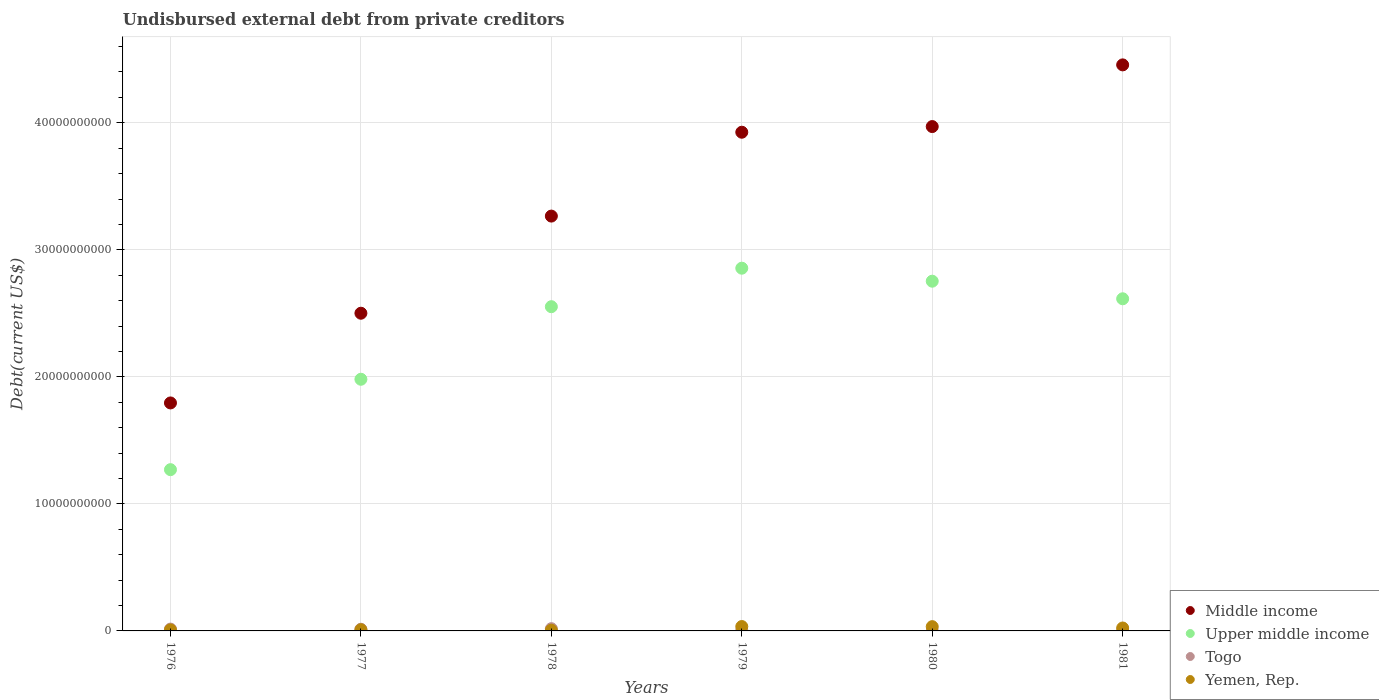How many different coloured dotlines are there?
Provide a succinct answer. 4. What is the total debt in Upper middle income in 1976?
Offer a terse response. 1.27e+1. Across all years, what is the maximum total debt in Middle income?
Your response must be concise. 4.46e+1. Across all years, what is the minimum total debt in Yemen, Rep.?
Your answer should be compact. 5.78e+07. In which year was the total debt in Upper middle income maximum?
Keep it short and to the point. 1979. In which year was the total debt in Middle income minimum?
Offer a very short reply. 1976. What is the total total debt in Upper middle income in the graph?
Your response must be concise. 1.40e+11. What is the difference between the total debt in Upper middle income in 1978 and that in 1980?
Make the answer very short. -2.01e+09. What is the difference between the total debt in Yemen, Rep. in 1980 and the total debt in Upper middle income in 1976?
Offer a very short reply. -1.24e+1. What is the average total debt in Togo per year?
Make the answer very short. 8.50e+07. In the year 1978, what is the difference between the total debt in Yemen, Rep. and total debt in Togo?
Provide a succinct answer. -1.19e+08. What is the ratio of the total debt in Middle income in 1976 to that in 1977?
Your answer should be very brief. 0.72. What is the difference between the highest and the second highest total debt in Togo?
Ensure brevity in your answer.  3.24e+07. What is the difference between the highest and the lowest total debt in Middle income?
Offer a very short reply. 2.66e+1. Is it the case that in every year, the sum of the total debt in Togo and total debt in Middle income  is greater than the sum of total debt in Upper middle income and total debt in Yemen, Rep.?
Offer a terse response. Yes. Is it the case that in every year, the sum of the total debt in Upper middle income and total debt in Togo  is greater than the total debt in Yemen, Rep.?
Keep it short and to the point. Yes. Is the total debt in Yemen, Rep. strictly greater than the total debt in Togo over the years?
Ensure brevity in your answer.  No. Is the total debt in Upper middle income strictly less than the total debt in Togo over the years?
Keep it short and to the point. No. Does the graph contain any zero values?
Offer a terse response. No. Does the graph contain grids?
Your answer should be very brief. Yes. Where does the legend appear in the graph?
Your answer should be very brief. Bottom right. How are the legend labels stacked?
Make the answer very short. Vertical. What is the title of the graph?
Give a very brief answer. Undisbursed external debt from private creditors. Does "Kiribati" appear as one of the legend labels in the graph?
Offer a very short reply. No. What is the label or title of the X-axis?
Ensure brevity in your answer.  Years. What is the label or title of the Y-axis?
Give a very brief answer. Debt(current US$). What is the Debt(current US$) of Middle income in 1976?
Your response must be concise. 1.79e+1. What is the Debt(current US$) of Upper middle income in 1976?
Give a very brief answer. 1.27e+1. What is the Debt(current US$) in Togo in 1976?
Offer a very short reply. 1.44e+08. What is the Debt(current US$) in Yemen, Rep. in 1976?
Offer a very short reply. 8.22e+07. What is the Debt(current US$) in Middle income in 1977?
Make the answer very short. 2.50e+1. What is the Debt(current US$) of Upper middle income in 1977?
Ensure brevity in your answer.  1.98e+1. What is the Debt(current US$) in Togo in 1977?
Provide a short and direct response. 1.32e+08. What is the Debt(current US$) in Yemen, Rep. in 1977?
Make the answer very short. 9.27e+07. What is the Debt(current US$) in Middle income in 1978?
Offer a very short reply. 3.27e+1. What is the Debt(current US$) in Upper middle income in 1978?
Provide a succinct answer. 2.55e+1. What is the Debt(current US$) of Togo in 1978?
Keep it short and to the point. 1.77e+08. What is the Debt(current US$) of Yemen, Rep. in 1978?
Provide a short and direct response. 5.78e+07. What is the Debt(current US$) of Middle income in 1979?
Provide a succinct answer. 3.93e+1. What is the Debt(current US$) of Upper middle income in 1979?
Provide a short and direct response. 2.86e+1. What is the Debt(current US$) in Togo in 1979?
Provide a short and direct response. 5.28e+07. What is the Debt(current US$) of Yemen, Rep. in 1979?
Ensure brevity in your answer.  3.45e+08. What is the Debt(current US$) in Middle income in 1980?
Give a very brief answer. 3.97e+1. What is the Debt(current US$) in Upper middle income in 1980?
Provide a short and direct response. 2.75e+1. What is the Debt(current US$) in Togo in 1980?
Your answer should be compact. 3.05e+06. What is the Debt(current US$) in Yemen, Rep. in 1980?
Ensure brevity in your answer.  3.36e+08. What is the Debt(current US$) of Middle income in 1981?
Provide a short and direct response. 4.46e+1. What is the Debt(current US$) in Upper middle income in 1981?
Ensure brevity in your answer.  2.61e+1. What is the Debt(current US$) in Togo in 1981?
Your response must be concise. 1.08e+06. What is the Debt(current US$) in Yemen, Rep. in 1981?
Ensure brevity in your answer.  2.31e+08. Across all years, what is the maximum Debt(current US$) of Middle income?
Provide a short and direct response. 4.46e+1. Across all years, what is the maximum Debt(current US$) of Upper middle income?
Keep it short and to the point. 2.86e+1. Across all years, what is the maximum Debt(current US$) in Togo?
Your response must be concise. 1.77e+08. Across all years, what is the maximum Debt(current US$) in Yemen, Rep.?
Give a very brief answer. 3.45e+08. Across all years, what is the minimum Debt(current US$) of Middle income?
Your answer should be very brief. 1.79e+1. Across all years, what is the minimum Debt(current US$) of Upper middle income?
Ensure brevity in your answer.  1.27e+1. Across all years, what is the minimum Debt(current US$) of Togo?
Provide a short and direct response. 1.08e+06. Across all years, what is the minimum Debt(current US$) of Yemen, Rep.?
Keep it short and to the point. 5.78e+07. What is the total Debt(current US$) in Middle income in the graph?
Your answer should be very brief. 1.99e+11. What is the total Debt(current US$) in Upper middle income in the graph?
Your answer should be very brief. 1.40e+11. What is the total Debt(current US$) in Togo in the graph?
Provide a short and direct response. 5.10e+08. What is the total Debt(current US$) of Yemen, Rep. in the graph?
Keep it short and to the point. 1.14e+09. What is the difference between the Debt(current US$) of Middle income in 1976 and that in 1977?
Make the answer very short. -7.06e+09. What is the difference between the Debt(current US$) in Upper middle income in 1976 and that in 1977?
Offer a terse response. -7.12e+09. What is the difference between the Debt(current US$) in Togo in 1976 and that in 1977?
Provide a short and direct response. 1.22e+07. What is the difference between the Debt(current US$) in Yemen, Rep. in 1976 and that in 1977?
Keep it short and to the point. -1.05e+07. What is the difference between the Debt(current US$) in Middle income in 1976 and that in 1978?
Offer a very short reply. -1.47e+1. What is the difference between the Debt(current US$) of Upper middle income in 1976 and that in 1978?
Provide a succinct answer. -1.28e+1. What is the difference between the Debt(current US$) in Togo in 1976 and that in 1978?
Your answer should be compact. -3.24e+07. What is the difference between the Debt(current US$) of Yemen, Rep. in 1976 and that in 1978?
Provide a short and direct response. 2.44e+07. What is the difference between the Debt(current US$) in Middle income in 1976 and that in 1979?
Give a very brief answer. -2.13e+1. What is the difference between the Debt(current US$) of Upper middle income in 1976 and that in 1979?
Offer a very short reply. -1.59e+1. What is the difference between the Debt(current US$) of Togo in 1976 and that in 1979?
Your answer should be compact. 9.14e+07. What is the difference between the Debt(current US$) in Yemen, Rep. in 1976 and that in 1979?
Your response must be concise. -2.63e+08. What is the difference between the Debt(current US$) in Middle income in 1976 and that in 1980?
Your answer should be very brief. -2.18e+1. What is the difference between the Debt(current US$) in Upper middle income in 1976 and that in 1980?
Make the answer very short. -1.48e+1. What is the difference between the Debt(current US$) of Togo in 1976 and that in 1980?
Your response must be concise. 1.41e+08. What is the difference between the Debt(current US$) of Yemen, Rep. in 1976 and that in 1980?
Offer a very short reply. -2.54e+08. What is the difference between the Debt(current US$) of Middle income in 1976 and that in 1981?
Provide a short and direct response. -2.66e+1. What is the difference between the Debt(current US$) of Upper middle income in 1976 and that in 1981?
Your answer should be compact. -1.35e+1. What is the difference between the Debt(current US$) in Togo in 1976 and that in 1981?
Offer a very short reply. 1.43e+08. What is the difference between the Debt(current US$) of Yemen, Rep. in 1976 and that in 1981?
Your answer should be very brief. -1.49e+08. What is the difference between the Debt(current US$) of Middle income in 1977 and that in 1978?
Your response must be concise. -7.65e+09. What is the difference between the Debt(current US$) of Upper middle income in 1977 and that in 1978?
Your response must be concise. -5.71e+09. What is the difference between the Debt(current US$) of Togo in 1977 and that in 1978?
Your answer should be very brief. -4.46e+07. What is the difference between the Debt(current US$) of Yemen, Rep. in 1977 and that in 1978?
Your response must be concise. 3.49e+07. What is the difference between the Debt(current US$) of Middle income in 1977 and that in 1979?
Your answer should be compact. -1.42e+1. What is the difference between the Debt(current US$) of Upper middle income in 1977 and that in 1979?
Give a very brief answer. -8.74e+09. What is the difference between the Debt(current US$) of Togo in 1977 and that in 1979?
Give a very brief answer. 7.92e+07. What is the difference between the Debt(current US$) of Yemen, Rep. in 1977 and that in 1979?
Your answer should be very brief. -2.52e+08. What is the difference between the Debt(current US$) in Middle income in 1977 and that in 1980?
Keep it short and to the point. -1.47e+1. What is the difference between the Debt(current US$) of Upper middle income in 1977 and that in 1980?
Make the answer very short. -7.72e+09. What is the difference between the Debt(current US$) in Togo in 1977 and that in 1980?
Provide a succinct answer. 1.29e+08. What is the difference between the Debt(current US$) in Yemen, Rep. in 1977 and that in 1980?
Provide a succinct answer. -2.44e+08. What is the difference between the Debt(current US$) of Middle income in 1977 and that in 1981?
Offer a very short reply. -1.96e+1. What is the difference between the Debt(current US$) of Upper middle income in 1977 and that in 1981?
Your response must be concise. -6.34e+09. What is the difference between the Debt(current US$) in Togo in 1977 and that in 1981?
Offer a very short reply. 1.31e+08. What is the difference between the Debt(current US$) of Yemen, Rep. in 1977 and that in 1981?
Offer a very short reply. -1.38e+08. What is the difference between the Debt(current US$) in Middle income in 1978 and that in 1979?
Keep it short and to the point. -6.60e+09. What is the difference between the Debt(current US$) in Upper middle income in 1978 and that in 1979?
Keep it short and to the point. -3.03e+09. What is the difference between the Debt(current US$) in Togo in 1978 and that in 1979?
Your response must be concise. 1.24e+08. What is the difference between the Debt(current US$) in Yemen, Rep. in 1978 and that in 1979?
Ensure brevity in your answer.  -2.87e+08. What is the difference between the Debt(current US$) of Middle income in 1978 and that in 1980?
Offer a terse response. -7.05e+09. What is the difference between the Debt(current US$) of Upper middle income in 1978 and that in 1980?
Offer a terse response. -2.01e+09. What is the difference between the Debt(current US$) of Togo in 1978 and that in 1980?
Keep it short and to the point. 1.74e+08. What is the difference between the Debt(current US$) in Yemen, Rep. in 1978 and that in 1980?
Make the answer very short. -2.78e+08. What is the difference between the Debt(current US$) in Middle income in 1978 and that in 1981?
Give a very brief answer. -1.19e+1. What is the difference between the Debt(current US$) of Upper middle income in 1978 and that in 1981?
Offer a terse response. -6.23e+08. What is the difference between the Debt(current US$) of Togo in 1978 and that in 1981?
Your answer should be very brief. 1.76e+08. What is the difference between the Debt(current US$) in Yemen, Rep. in 1978 and that in 1981?
Give a very brief answer. -1.73e+08. What is the difference between the Debt(current US$) of Middle income in 1979 and that in 1980?
Make the answer very short. -4.46e+08. What is the difference between the Debt(current US$) of Upper middle income in 1979 and that in 1980?
Provide a short and direct response. 1.02e+09. What is the difference between the Debt(current US$) in Togo in 1979 and that in 1980?
Make the answer very short. 4.98e+07. What is the difference between the Debt(current US$) in Yemen, Rep. in 1979 and that in 1980?
Make the answer very short. 8.80e+06. What is the difference between the Debt(current US$) of Middle income in 1979 and that in 1981?
Ensure brevity in your answer.  -5.30e+09. What is the difference between the Debt(current US$) of Upper middle income in 1979 and that in 1981?
Your answer should be very brief. 2.41e+09. What is the difference between the Debt(current US$) in Togo in 1979 and that in 1981?
Offer a terse response. 5.18e+07. What is the difference between the Debt(current US$) of Yemen, Rep. in 1979 and that in 1981?
Offer a very short reply. 1.14e+08. What is the difference between the Debt(current US$) in Middle income in 1980 and that in 1981?
Make the answer very short. -4.86e+09. What is the difference between the Debt(current US$) in Upper middle income in 1980 and that in 1981?
Offer a terse response. 1.38e+09. What is the difference between the Debt(current US$) in Togo in 1980 and that in 1981?
Provide a short and direct response. 1.98e+06. What is the difference between the Debt(current US$) in Yemen, Rep. in 1980 and that in 1981?
Offer a very short reply. 1.05e+08. What is the difference between the Debt(current US$) in Middle income in 1976 and the Debt(current US$) in Upper middle income in 1977?
Ensure brevity in your answer.  -1.86e+09. What is the difference between the Debt(current US$) in Middle income in 1976 and the Debt(current US$) in Togo in 1977?
Offer a terse response. 1.78e+1. What is the difference between the Debt(current US$) of Middle income in 1976 and the Debt(current US$) of Yemen, Rep. in 1977?
Offer a terse response. 1.79e+1. What is the difference between the Debt(current US$) in Upper middle income in 1976 and the Debt(current US$) in Togo in 1977?
Your response must be concise. 1.26e+1. What is the difference between the Debt(current US$) of Upper middle income in 1976 and the Debt(current US$) of Yemen, Rep. in 1977?
Ensure brevity in your answer.  1.26e+1. What is the difference between the Debt(current US$) in Togo in 1976 and the Debt(current US$) in Yemen, Rep. in 1977?
Your answer should be compact. 5.15e+07. What is the difference between the Debt(current US$) in Middle income in 1976 and the Debt(current US$) in Upper middle income in 1978?
Provide a succinct answer. -7.58e+09. What is the difference between the Debt(current US$) in Middle income in 1976 and the Debt(current US$) in Togo in 1978?
Keep it short and to the point. 1.78e+1. What is the difference between the Debt(current US$) in Middle income in 1976 and the Debt(current US$) in Yemen, Rep. in 1978?
Ensure brevity in your answer.  1.79e+1. What is the difference between the Debt(current US$) of Upper middle income in 1976 and the Debt(current US$) of Togo in 1978?
Your answer should be very brief. 1.25e+1. What is the difference between the Debt(current US$) in Upper middle income in 1976 and the Debt(current US$) in Yemen, Rep. in 1978?
Ensure brevity in your answer.  1.26e+1. What is the difference between the Debt(current US$) in Togo in 1976 and the Debt(current US$) in Yemen, Rep. in 1978?
Make the answer very short. 8.64e+07. What is the difference between the Debt(current US$) in Middle income in 1976 and the Debt(current US$) in Upper middle income in 1979?
Ensure brevity in your answer.  -1.06e+1. What is the difference between the Debt(current US$) of Middle income in 1976 and the Debt(current US$) of Togo in 1979?
Offer a terse response. 1.79e+1. What is the difference between the Debt(current US$) of Middle income in 1976 and the Debt(current US$) of Yemen, Rep. in 1979?
Make the answer very short. 1.76e+1. What is the difference between the Debt(current US$) in Upper middle income in 1976 and the Debt(current US$) in Togo in 1979?
Provide a short and direct response. 1.26e+1. What is the difference between the Debt(current US$) in Upper middle income in 1976 and the Debt(current US$) in Yemen, Rep. in 1979?
Your answer should be very brief. 1.23e+1. What is the difference between the Debt(current US$) in Togo in 1976 and the Debt(current US$) in Yemen, Rep. in 1979?
Your answer should be compact. -2.01e+08. What is the difference between the Debt(current US$) of Middle income in 1976 and the Debt(current US$) of Upper middle income in 1980?
Your response must be concise. -9.58e+09. What is the difference between the Debt(current US$) of Middle income in 1976 and the Debt(current US$) of Togo in 1980?
Provide a short and direct response. 1.79e+1. What is the difference between the Debt(current US$) of Middle income in 1976 and the Debt(current US$) of Yemen, Rep. in 1980?
Provide a succinct answer. 1.76e+1. What is the difference between the Debt(current US$) of Upper middle income in 1976 and the Debt(current US$) of Togo in 1980?
Your answer should be compact. 1.27e+1. What is the difference between the Debt(current US$) of Upper middle income in 1976 and the Debt(current US$) of Yemen, Rep. in 1980?
Provide a succinct answer. 1.24e+1. What is the difference between the Debt(current US$) in Togo in 1976 and the Debt(current US$) in Yemen, Rep. in 1980?
Provide a short and direct response. -1.92e+08. What is the difference between the Debt(current US$) in Middle income in 1976 and the Debt(current US$) in Upper middle income in 1981?
Your answer should be very brief. -8.20e+09. What is the difference between the Debt(current US$) of Middle income in 1976 and the Debt(current US$) of Togo in 1981?
Provide a succinct answer. 1.79e+1. What is the difference between the Debt(current US$) of Middle income in 1976 and the Debt(current US$) of Yemen, Rep. in 1981?
Offer a terse response. 1.77e+1. What is the difference between the Debt(current US$) of Upper middle income in 1976 and the Debt(current US$) of Togo in 1981?
Your response must be concise. 1.27e+1. What is the difference between the Debt(current US$) of Upper middle income in 1976 and the Debt(current US$) of Yemen, Rep. in 1981?
Offer a very short reply. 1.25e+1. What is the difference between the Debt(current US$) in Togo in 1976 and the Debt(current US$) in Yemen, Rep. in 1981?
Ensure brevity in your answer.  -8.66e+07. What is the difference between the Debt(current US$) in Middle income in 1977 and the Debt(current US$) in Upper middle income in 1978?
Your answer should be compact. -5.14e+08. What is the difference between the Debt(current US$) in Middle income in 1977 and the Debt(current US$) in Togo in 1978?
Give a very brief answer. 2.48e+1. What is the difference between the Debt(current US$) in Middle income in 1977 and the Debt(current US$) in Yemen, Rep. in 1978?
Provide a succinct answer. 2.50e+1. What is the difference between the Debt(current US$) in Upper middle income in 1977 and the Debt(current US$) in Togo in 1978?
Make the answer very short. 1.96e+1. What is the difference between the Debt(current US$) in Upper middle income in 1977 and the Debt(current US$) in Yemen, Rep. in 1978?
Provide a short and direct response. 1.98e+1. What is the difference between the Debt(current US$) of Togo in 1977 and the Debt(current US$) of Yemen, Rep. in 1978?
Give a very brief answer. 7.42e+07. What is the difference between the Debt(current US$) in Middle income in 1977 and the Debt(current US$) in Upper middle income in 1979?
Offer a very short reply. -3.55e+09. What is the difference between the Debt(current US$) of Middle income in 1977 and the Debt(current US$) of Togo in 1979?
Give a very brief answer. 2.50e+1. What is the difference between the Debt(current US$) in Middle income in 1977 and the Debt(current US$) in Yemen, Rep. in 1979?
Offer a terse response. 2.47e+1. What is the difference between the Debt(current US$) in Upper middle income in 1977 and the Debt(current US$) in Togo in 1979?
Offer a terse response. 1.98e+1. What is the difference between the Debt(current US$) of Upper middle income in 1977 and the Debt(current US$) of Yemen, Rep. in 1979?
Your response must be concise. 1.95e+1. What is the difference between the Debt(current US$) of Togo in 1977 and the Debt(current US$) of Yemen, Rep. in 1979?
Offer a terse response. -2.13e+08. What is the difference between the Debt(current US$) of Middle income in 1977 and the Debt(current US$) of Upper middle income in 1980?
Offer a terse response. -2.52e+09. What is the difference between the Debt(current US$) of Middle income in 1977 and the Debt(current US$) of Togo in 1980?
Offer a very short reply. 2.50e+1. What is the difference between the Debt(current US$) in Middle income in 1977 and the Debt(current US$) in Yemen, Rep. in 1980?
Offer a very short reply. 2.47e+1. What is the difference between the Debt(current US$) of Upper middle income in 1977 and the Debt(current US$) of Togo in 1980?
Provide a succinct answer. 1.98e+1. What is the difference between the Debt(current US$) of Upper middle income in 1977 and the Debt(current US$) of Yemen, Rep. in 1980?
Your answer should be compact. 1.95e+1. What is the difference between the Debt(current US$) of Togo in 1977 and the Debt(current US$) of Yemen, Rep. in 1980?
Ensure brevity in your answer.  -2.04e+08. What is the difference between the Debt(current US$) in Middle income in 1977 and the Debt(current US$) in Upper middle income in 1981?
Your answer should be very brief. -1.14e+09. What is the difference between the Debt(current US$) in Middle income in 1977 and the Debt(current US$) in Togo in 1981?
Provide a short and direct response. 2.50e+1. What is the difference between the Debt(current US$) in Middle income in 1977 and the Debt(current US$) in Yemen, Rep. in 1981?
Ensure brevity in your answer.  2.48e+1. What is the difference between the Debt(current US$) of Upper middle income in 1977 and the Debt(current US$) of Togo in 1981?
Your answer should be compact. 1.98e+1. What is the difference between the Debt(current US$) of Upper middle income in 1977 and the Debt(current US$) of Yemen, Rep. in 1981?
Your response must be concise. 1.96e+1. What is the difference between the Debt(current US$) in Togo in 1977 and the Debt(current US$) in Yemen, Rep. in 1981?
Provide a short and direct response. -9.88e+07. What is the difference between the Debt(current US$) of Middle income in 1978 and the Debt(current US$) of Upper middle income in 1979?
Your answer should be very brief. 4.10e+09. What is the difference between the Debt(current US$) in Middle income in 1978 and the Debt(current US$) in Togo in 1979?
Provide a succinct answer. 3.26e+1. What is the difference between the Debt(current US$) of Middle income in 1978 and the Debt(current US$) of Yemen, Rep. in 1979?
Ensure brevity in your answer.  3.23e+1. What is the difference between the Debt(current US$) of Upper middle income in 1978 and the Debt(current US$) of Togo in 1979?
Ensure brevity in your answer.  2.55e+1. What is the difference between the Debt(current US$) in Upper middle income in 1978 and the Debt(current US$) in Yemen, Rep. in 1979?
Your answer should be very brief. 2.52e+1. What is the difference between the Debt(current US$) in Togo in 1978 and the Debt(current US$) in Yemen, Rep. in 1979?
Offer a terse response. -1.68e+08. What is the difference between the Debt(current US$) in Middle income in 1978 and the Debt(current US$) in Upper middle income in 1980?
Give a very brief answer. 5.13e+09. What is the difference between the Debt(current US$) in Middle income in 1978 and the Debt(current US$) in Togo in 1980?
Your answer should be compact. 3.27e+1. What is the difference between the Debt(current US$) in Middle income in 1978 and the Debt(current US$) in Yemen, Rep. in 1980?
Offer a terse response. 3.23e+1. What is the difference between the Debt(current US$) in Upper middle income in 1978 and the Debt(current US$) in Togo in 1980?
Provide a succinct answer. 2.55e+1. What is the difference between the Debt(current US$) in Upper middle income in 1978 and the Debt(current US$) in Yemen, Rep. in 1980?
Ensure brevity in your answer.  2.52e+1. What is the difference between the Debt(current US$) of Togo in 1978 and the Debt(current US$) of Yemen, Rep. in 1980?
Give a very brief answer. -1.60e+08. What is the difference between the Debt(current US$) in Middle income in 1978 and the Debt(current US$) in Upper middle income in 1981?
Your response must be concise. 6.51e+09. What is the difference between the Debt(current US$) of Middle income in 1978 and the Debt(current US$) of Togo in 1981?
Give a very brief answer. 3.27e+1. What is the difference between the Debt(current US$) of Middle income in 1978 and the Debt(current US$) of Yemen, Rep. in 1981?
Your answer should be compact. 3.24e+1. What is the difference between the Debt(current US$) in Upper middle income in 1978 and the Debt(current US$) in Togo in 1981?
Provide a succinct answer. 2.55e+1. What is the difference between the Debt(current US$) in Upper middle income in 1978 and the Debt(current US$) in Yemen, Rep. in 1981?
Your response must be concise. 2.53e+1. What is the difference between the Debt(current US$) in Togo in 1978 and the Debt(current US$) in Yemen, Rep. in 1981?
Offer a very short reply. -5.42e+07. What is the difference between the Debt(current US$) in Middle income in 1979 and the Debt(current US$) in Upper middle income in 1980?
Offer a terse response. 1.17e+1. What is the difference between the Debt(current US$) in Middle income in 1979 and the Debt(current US$) in Togo in 1980?
Provide a succinct answer. 3.93e+1. What is the difference between the Debt(current US$) of Middle income in 1979 and the Debt(current US$) of Yemen, Rep. in 1980?
Give a very brief answer. 3.89e+1. What is the difference between the Debt(current US$) in Upper middle income in 1979 and the Debt(current US$) in Togo in 1980?
Your answer should be compact. 2.86e+1. What is the difference between the Debt(current US$) of Upper middle income in 1979 and the Debt(current US$) of Yemen, Rep. in 1980?
Ensure brevity in your answer.  2.82e+1. What is the difference between the Debt(current US$) in Togo in 1979 and the Debt(current US$) in Yemen, Rep. in 1980?
Keep it short and to the point. -2.83e+08. What is the difference between the Debt(current US$) in Middle income in 1979 and the Debt(current US$) in Upper middle income in 1981?
Your answer should be very brief. 1.31e+1. What is the difference between the Debt(current US$) in Middle income in 1979 and the Debt(current US$) in Togo in 1981?
Your answer should be very brief. 3.93e+1. What is the difference between the Debt(current US$) in Middle income in 1979 and the Debt(current US$) in Yemen, Rep. in 1981?
Give a very brief answer. 3.90e+1. What is the difference between the Debt(current US$) of Upper middle income in 1979 and the Debt(current US$) of Togo in 1981?
Your answer should be very brief. 2.86e+1. What is the difference between the Debt(current US$) of Upper middle income in 1979 and the Debt(current US$) of Yemen, Rep. in 1981?
Ensure brevity in your answer.  2.83e+1. What is the difference between the Debt(current US$) of Togo in 1979 and the Debt(current US$) of Yemen, Rep. in 1981?
Ensure brevity in your answer.  -1.78e+08. What is the difference between the Debt(current US$) in Middle income in 1980 and the Debt(current US$) in Upper middle income in 1981?
Offer a very short reply. 1.36e+1. What is the difference between the Debt(current US$) in Middle income in 1980 and the Debt(current US$) in Togo in 1981?
Provide a short and direct response. 3.97e+1. What is the difference between the Debt(current US$) in Middle income in 1980 and the Debt(current US$) in Yemen, Rep. in 1981?
Your response must be concise. 3.95e+1. What is the difference between the Debt(current US$) of Upper middle income in 1980 and the Debt(current US$) of Togo in 1981?
Your answer should be compact. 2.75e+1. What is the difference between the Debt(current US$) in Upper middle income in 1980 and the Debt(current US$) in Yemen, Rep. in 1981?
Your response must be concise. 2.73e+1. What is the difference between the Debt(current US$) of Togo in 1980 and the Debt(current US$) of Yemen, Rep. in 1981?
Your response must be concise. -2.28e+08. What is the average Debt(current US$) in Middle income per year?
Make the answer very short. 3.32e+1. What is the average Debt(current US$) in Upper middle income per year?
Ensure brevity in your answer.  2.34e+1. What is the average Debt(current US$) of Togo per year?
Ensure brevity in your answer.  8.50e+07. What is the average Debt(current US$) of Yemen, Rep. per year?
Offer a terse response. 1.91e+08. In the year 1976, what is the difference between the Debt(current US$) in Middle income and Debt(current US$) in Upper middle income?
Give a very brief answer. 5.25e+09. In the year 1976, what is the difference between the Debt(current US$) of Middle income and Debt(current US$) of Togo?
Keep it short and to the point. 1.78e+1. In the year 1976, what is the difference between the Debt(current US$) of Middle income and Debt(current US$) of Yemen, Rep.?
Offer a terse response. 1.79e+1. In the year 1976, what is the difference between the Debt(current US$) of Upper middle income and Debt(current US$) of Togo?
Offer a terse response. 1.26e+1. In the year 1976, what is the difference between the Debt(current US$) of Upper middle income and Debt(current US$) of Yemen, Rep.?
Your response must be concise. 1.26e+1. In the year 1976, what is the difference between the Debt(current US$) in Togo and Debt(current US$) in Yemen, Rep.?
Your answer should be compact. 6.20e+07. In the year 1977, what is the difference between the Debt(current US$) in Middle income and Debt(current US$) in Upper middle income?
Make the answer very short. 5.20e+09. In the year 1977, what is the difference between the Debt(current US$) in Middle income and Debt(current US$) in Togo?
Keep it short and to the point. 2.49e+1. In the year 1977, what is the difference between the Debt(current US$) in Middle income and Debt(current US$) in Yemen, Rep.?
Offer a very short reply. 2.49e+1. In the year 1977, what is the difference between the Debt(current US$) of Upper middle income and Debt(current US$) of Togo?
Give a very brief answer. 1.97e+1. In the year 1977, what is the difference between the Debt(current US$) of Upper middle income and Debt(current US$) of Yemen, Rep.?
Offer a very short reply. 1.97e+1. In the year 1977, what is the difference between the Debt(current US$) of Togo and Debt(current US$) of Yemen, Rep.?
Provide a short and direct response. 3.93e+07. In the year 1978, what is the difference between the Debt(current US$) of Middle income and Debt(current US$) of Upper middle income?
Your response must be concise. 7.13e+09. In the year 1978, what is the difference between the Debt(current US$) of Middle income and Debt(current US$) of Togo?
Ensure brevity in your answer.  3.25e+1. In the year 1978, what is the difference between the Debt(current US$) in Middle income and Debt(current US$) in Yemen, Rep.?
Provide a succinct answer. 3.26e+1. In the year 1978, what is the difference between the Debt(current US$) in Upper middle income and Debt(current US$) in Togo?
Make the answer very short. 2.53e+1. In the year 1978, what is the difference between the Debt(current US$) in Upper middle income and Debt(current US$) in Yemen, Rep.?
Provide a succinct answer. 2.55e+1. In the year 1978, what is the difference between the Debt(current US$) in Togo and Debt(current US$) in Yemen, Rep.?
Keep it short and to the point. 1.19e+08. In the year 1979, what is the difference between the Debt(current US$) in Middle income and Debt(current US$) in Upper middle income?
Your response must be concise. 1.07e+1. In the year 1979, what is the difference between the Debt(current US$) in Middle income and Debt(current US$) in Togo?
Offer a very short reply. 3.92e+1. In the year 1979, what is the difference between the Debt(current US$) in Middle income and Debt(current US$) in Yemen, Rep.?
Ensure brevity in your answer.  3.89e+1. In the year 1979, what is the difference between the Debt(current US$) in Upper middle income and Debt(current US$) in Togo?
Offer a very short reply. 2.85e+1. In the year 1979, what is the difference between the Debt(current US$) of Upper middle income and Debt(current US$) of Yemen, Rep.?
Offer a very short reply. 2.82e+1. In the year 1979, what is the difference between the Debt(current US$) in Togo and Debt(current US$) in Yemen, Rep.?
Provide a succinct answer. -2.92e+08. In the year 1980, what is the difference between the Debt(current US$) of Middle income and Debt(current US$) of Upper middle income?
Provide a succinct answer. 1.22e+1. In the year 1980, what is the difference between the Debt(current US$) in Middle income and Debt(current US$) in Togo?
Offer a very short reply. 3.97e+1. In the year 1980, what is the difference between the Debt(current US$) of Middle income and Debt(current US$) of Yemen, Rep.?
Ensure brevity in your answer.  3.94e+1. In the year 1980, what is the difference between the Debt(current US$) of Upper middle income and Debt(current US$) of Togo?
Ensure brevity in your answer.  2.75e+1. In the year 1980, what is the difference between the Debt(current US$) in Upper middle income and Debt(current US$) in Yemen, Rep.?
Make the answer very short. 2.72e+1. In the year 1980, what is the difference between the Debt(current US$) in Togo and Debt(current US$) in Yemen, Rep.?
Your answer should be very brief. -3.33e+08. In the year 1981, what is the difference between the Debt(current US$) in Middle income and Debt(current US$) in Upper middle income?
Your answer should be very brief. 1.84e+1. In the year 1981, what is the difference between the Debt(current US$) of Middle income and Debt(current US$) of Togo?
Make the answer very short. 4.46e+1. In the year 1981, what is the difference between the Debt(current US$) of Middle income and Debt(current US$) of Yemen, Rep.?
Your answer should be very brief. 4.43e+1. In the year 1981, what is the difference between the Debt(current US$) of Upper middle income and Debt(current US$) of Togo?
Ensure brevity in your answer.  2.61e+1. In the year 1981, what is the difference between the Debt(current US$) of Upper middle income and Debt(current US$) of Yemen, Rep.?
Your answer should be very brief. 2.59e+1. In the year 1981, what is the difference between the Debt(current US$) of Togo and Debt(current US$) of Yemen, Rep.?
Your response must be concise. -2.30e+08. What is the ratio of the Debt(current US$) of Middle income in 1976 to that in 1977?
Make the answer very short. 0.72. What is the ratio of the Debt(current US$) of Upper middle income in 1976 to that in 1977?
Offer a terse response. 0.64. What is the ratio of the Debt(current US$) in Togo in 1976 to that in 1977?
Your response must be concise. 1.09. What is the ratio of the Debt(current US$) in Yemen, Rep. in 1976 to that in 1977?
Your answer should be compact. 0.89. What is the ratio of the Debt(current US$) of Middle income in 1976 to that in 1978?
Ensure brevity in your answer.  0.55. What is the ratio of the Debt(current US$) of Upper middle income in 1976 to that in 1978?
Your response must be concise. 0.5. What is the ratio of the Debt(current US$) of Togo in 1976 to that in 1978?
Keep it short and to the point. 0.82. What is the ratio of the Debt(current US$) in Yemen, Rep. in 1976 to that in 1978?
Offer a very short reply. 1.42. What is the ratio of the Debt(current US$) in Middle income in 1976 to that in 1979?
Your answer should be compact. 0.46. What is the ratio of the Debt(current US$) of Upper middle income in 1976 to that in 1979?
Your response must be concise. 0.44. What is the ratio of the Debt(current US$) in Togo in 1976 to that in 1979?
Offer a terse response. 2.73. What is the ratio of the Debt(current US$) of Yemen, Rep. in 1976 to that in 1979?
Ensure brevity in your answer.  0.24. What is the ratio of the Debt(current US$) in Middle income in 1976 to that in 1980?
Provide a short and direct response. 0.45. What is the ratio of the Debt(current US$) of Upper middle income in 1976 to that in 1980?
Ensure brevity in your answer.  0.46. What is the ratio of the Debt(current US$) in Togo in 1976 to that in 1980?
Make the answer very short. 47.22. What is the ratio of the Debt(current US$) of Yemen, Rep. in 1976 to that in 1980?
Offer a very short reply. 0.24. What is the ratio of the Debt(current US$) of Middle income in 1976 to that in 1981?
Offer a terse response. 0.4. What is the ratio of the Debt(current US$) in Upper middle income in 1976 to that in 1981?
Offer a terse response. 0.49. What is the ratio of the Debt(current US$) in Togo in 1976 to that in 1981?
Your answer should be compact. 133.9. What is the ratio of the Debt(current US$) of Yemen, Rep. in 1976 to that in 1981?
Make the answer very short. 0.36. What is the ratio of the Debt(current US$) of Middle income in 1977 to that in 1978?
Provide a short and direct response. 0.77. What is the ratio of the Debt(current US$) in Upper middle income in 1977 to that in 1978?
Offer a very short reply. 0.78. What is the ratio of the Debt(current US$) of Togo in 1977 to that in 1978?
Provide a succinct answer. 0.75. What is the ratio of the Debt(current US$) in Yemen, Rep. in 1977 to that in 1978?
Make the answer very short. 1.6. What is the ratio of the Debt(current US$) of Middle income in 1977 to that in 1979?
Give a very brief answer. 0.64. What is the ratio of the Debt(current US$) of Upper middle income in 1977 to that in 1979?
Your response must be concise. 0.69. What is the ratio of the Debt(current US$) in Togo in 1977 to that in 1979?
Your answer should be very brief. 2.5. What is the ratio of the Debt(current US$) in Yemen, Rep. in 1977 to that in 1979?
Ensure brevity in your answer.  0.27. What is the ratio of the Debt(current US$) of Middle income in 1977 to that in 1980?
Keep it short and to the point. 0.63. What is the ratio of the Debt(current US$) in Upper middle income in 1977 to that in 1980?
Your answer should be compact. 0.72. What is the ratio of the Debt(current US$) of Togo in 1977 to that in 1980?
Provide a succinct answer. 43.23. What is the ratio of the Debt(current US$) of Yemen, Rep. in 1977 to that in 1980?
Your response must be concise. 0.28. What is the ratio of the Debt(current US$) in Middle income in 1977 to that in 1981?
Your response must be concise. 0.56. What is the ratio of the Debt(current US$) in Upper middle income in 1977 to that in 1981?
Your answer should be compact. 0.76. What is the ratio of the Debt(current US$) in Togo in 1977 to that in 1981?
Provide a short and direct response. 122.58. What is the ratio of the Debt(current US$) in Yemen, Rep. in 1977 to that in 1981?
Your response must be concise. 0.4. What is the ratio of the Debt(current US$) in Middle income in 1978 to that in 1979?
Ensure brevity in your answer.  0.83. What is the ratio of the Debt(current US$) of Upper middle income in 1978 to that in 1979?
Your response must be concise. 0.89. What is the ratio of the Debt(current US$) in Togo in 1978 to that in 1979?
Your answer should be compact. 3.34. What is the ratio of the Debt(current US$) in Yemen, Rep. in 1978 to that in 1979?
Ensure brevity in your answer.  0.17. What is the ratio of the Debt(current US$) of Middle income in 1978 to that in 1980?
Give a very brief answer. 0.82. What is the ratio of the Debt(current US$) of Upper middle income in 1978 to that in 1980?
Give a very brief answer. 0.93. What is the ratio of the Debt(current US$) in Togo in 1978 to that in 1980?
Give a very brief answer. 57.83. What is the ratio of the Debt(current US$) in Yemen, Rep. in 1978 to that in 1980?
Your answer should be very brief. 0.17. What is the ratio of the Debt(current US$) in Middle income in 1978 to that in 1981?
Your answer should be very brief. 0.73. What is the ratio of the Debt(current US$) in Upper middle income in 1978 to that in 1981?
Make the answer very short. 0.98. What is the ratio of the Debt(current US$) in Togo in 1978 to that in 1981?
Give a very brief answer. 163.97. What is the ratio of the Debt(current US$) of Yemen, Rep. in 1978 to that in 1981?
Give a very brief answer. 0.25. What is the ratio of the Debt(current US$) of Middle income in 1979 to that in 1980?
Your answer should be very brief. 0.99. What is the ratio of the Debt(current US$) in Upper middle income in 1979 to that in 1980?
Provide a short and direct response. 1.04. What is the ratio of the Debt(current US$) of Togo in 1979 to that in 1980?
Provide a succinct answer. 17.3. What is the ratio of the Debt(current US$) of Yemen, Rep. in 1979 to that in 1980?
Give a very brief answer. 1.03. What is the ratio of the Debt(current US$) of Middle income in 1979 to that in 1981?
Give a very brief answer. 0.88. What is the ratio of the Debt(current US$) of Upper middle income in 1979 to that in 1981?
Provide a short and direct response. 1.09. What is the ratio of the Debt(current US$) of Togo in 1979 to that in 1981?
Your response must be concise. 49.06. What is the ratio of the Debt(current US$) in Yemen, Rep. in 1979 to that in 1981?
Give a very brief answer. 1.5. What is the ratio of the Debt(current US$) of Middle income in 1980 to that in 1981?
Offer a terse response. 0.89. What is the ratio of the Debt(current US$) in Upper middle income in 1980 to that in 1981?
Provide a short and direct response. 1.05. What is the ratio of the Debt(current US$) of Togo in 1980 to that in 1981?
Offer a terse response. 2.84. What is the ratio of the Debt(current US$) of Yemen, Rep. in 1980 to that in 1981?
Your answer should be compact. 1.46. What is the difference between the highest and the second highest Debt(current US$) in Middle income?
Your answer should be very brief. 4.86e+09. What is the difference between the highest and the second highest Debt(current US$) of Upper middle income?
Ensure brevity in your answer.  1.02e+09. What is the difference between the highest and the second highest Debt(current US$) of Togo?
Keep it short and to the point. 3.24e+07. What is the difference between the highest and the second highest Debt(current US$) in Yemen, Rep.?
Provide a short and direct response. 8.80e+06. What is the difference between the highest and the lowest Debt(current US$) of Middle income?
Offer a very short reply. 2.66e+1. What is the difference between the highest and the lowest Debt(current US$) of Upper middle income?
Provide a succinct answer. 1.59e+1. What is the difference between the highest and the lowest Debt(current US$) in Togo?
Make the answer very short. 1.76e+08. What is the difference between the highest and the lowest Debt(current US$) in Yemen, Rep.?
Make the answer very short. 2.87e+08. 